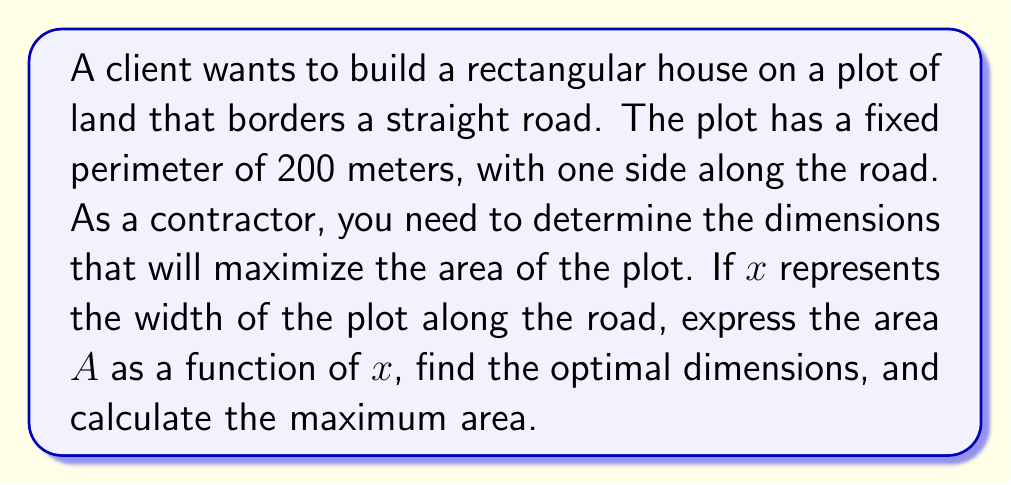Show me your answer to this math problem. 1) Let's define our variables:
   $x$ = width of the plot along the road
   $y$ = depth of the plot perpendicular to the road
   
2) Given the perimeter is 200 meters, we can write:
   $2x + 2y = 200$
   
3) Solve for $y$:
   $y = 100 - x$
   
4) The area of the rectangle is given by $A = xy$. Substituting for $y$:
   $A = x(100-x) = 100x - x^2$
   
5) To find the maximum area, we need to find the vertex of this quadratic function. We can do this by finding where the derivative equals zero:
   $\frac{dA}{dx} = 100 - 2x$
   
6) Set the derivative to zero and solve:
   $100 - 2x = 0$
   $2x = 100$
   $x = 50$
   
7) This critical point will give us the maximum area because the coefficient of $x^2$ in our area function is negative.

8) Calculate $y$ when $x = 50$:
   $y = 100 - 50 = 50$
   
9) Calculate the maximum area:
   $A_{max} = 50 * 50 = 2500$

[asy]
size(200);
draw((0,0)--(100,0)--(100,50)--(0,50)--cycle);
label("50m", (50,0), S);
label("50m", (100,25), E);
label("Road", (50,-10));
[/asy]
Answer: Optimal dimensions: 50m x 50m; Maximum area: 2500 m² 